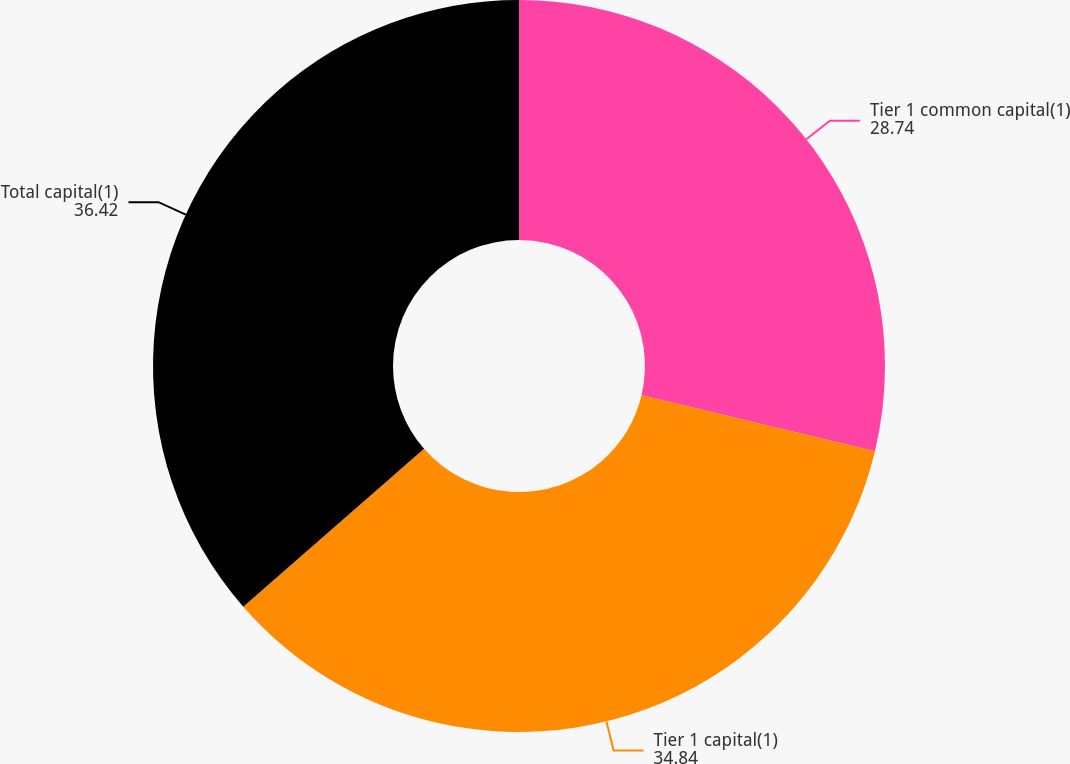<chart> <loc_0><loc_0><loc_500><loc_500><pie_chart><fcel>Tier 1 common capital(1)<fcel>Tier 1 capital(1)<fcel>Total capital(1)<nl><fcel>28.74%<fcel>34.84%<fcel>36.42%<nl></chart> 